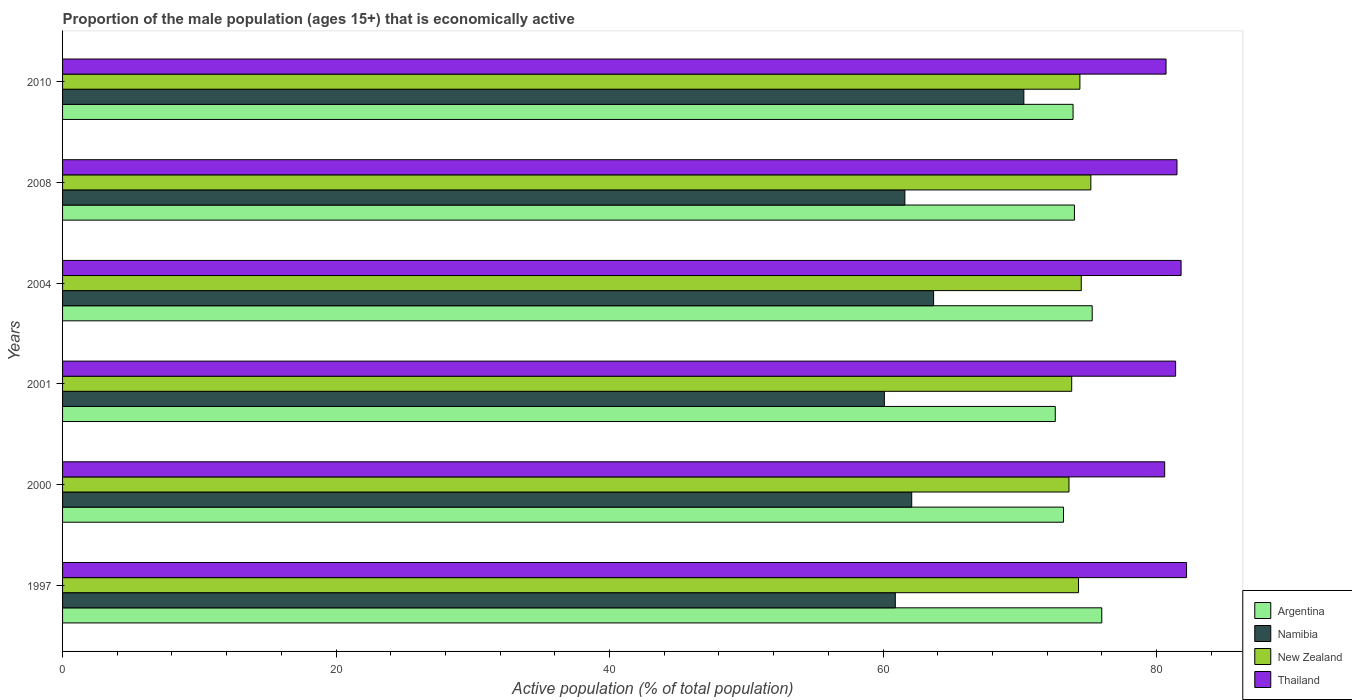How many groups of bars are there?
Ensure brevity in your answer.  6. Are the number of bars per tick equal to the number of legend labels?
Provide a succinct answer. Yes. Are the number of bars on each tick of the Y-axis equal?
Make the answer very short. Yes. How many bars are there on the 2nd tick from the top?
Provide a succinct answer. 4. What is the label of the 5th group of bars from the top?
Provide a succinct answer. 2000. What is the proportion of the male population that is economically active in Argentina in 2004?
Your answer should be compact. 75.3. Across all years, what is the maximum proportion of the male population that is economically active in Argentina?
Give a very brief answer. 76. Across all years, what is the minimum proportion of the male population that is economically active in Namibia?
Provide a short and direct response. 60.1. In which year was the proportion of the male population that is economically active in Namibia maximum?
Keep it short and to the point. 2010. What is the total proportion of the male population that is economically active in Argentina in the graph?
Make the answer very short. 445. What is the difference between the proportion of the male population that is economically active in Thailand in 2000 and that in 2008?
Make the answer very short. -0.9. What is the difference between the proportion of the male population that is economically active in New Zealand in 2010 and the proportion of the male population that is economically active in Namibia in 2000?
Make the answer very short. 12.3. What is the average proportion of the male population that is economically active in Namibia per year?
Keep it short and to the point. 63.12. In the year 2008, what is the difference between the proportion of the male population that is economically active in Namibia and proportion of the male population that is economically active in Thailand?
Your answer should be compact. -19.9. What is the ratio of the proportion of the male population that is economically active in Namibia in 2000 to that in 2008?
Give a very brief answer. 1.01. Is the proportion of the male population that is economically active in Namibia in 2000 less than that in 2001?
Your answer should be compact. No. Is the difference between the proportion of the male population that is economically active in Namibia in 2008 and 2010 greater than the difference between the proportion of the male population that is economically active in Thailand in 2008 and 2010?
Make the answer very short. No. What is the difference between the highest and the second highest proportion of the male population that is economically active in Argentina?
Your answer should be very brief. 0.7. What is the difference between the highest and the lowest proportion of the male population that is economically active in Thailand?
Offer a very short reply. 1.6. In how many years, is the proportion of the male population that is economically active in Thailand greater than the average proportion of the male population that is economically active in Thailand taken over all years?
Offer a terse response. 4. Is it the case that in every year, the sum of the proportion of the male population that is economically active in Argentina and proportion of the male population that is economically active in Namibia is greater than the sum of proportion of the male population that is economically active in Thailand and proportion of the male population that is economically active in New Zealand?
Your response must be concise. No. What does the 4th bar from the bottom in 2000 represents?
Keep it short and to the point. Thailand. Is it the case that in every year, the sum of the proportion of the male population that is economically active in New Zealand and proportion of the male population that is economically active in Thailand is greater than the proportion of the male population that is economically active in Namibia?
Keep it short and to the point. Yes. How many bars are there?
Make the answer very short. 24. What is the difference between two consecutive major ticks on the X-axis?
Your response must be concise. 20. Are the values on the major ticks of X-axis written in scientific E-notation?
Ensure brevity in your answer.  No. Does the graph contain any zero values?
Make the answer very short. No. Where does the legend appear in the graph?
Provide a succinct answer. Bottom right. How are the legend labels stacked?
Your response must be concise. Vertical. What is the title of the graph?
Your answer should be compact. Proportion of the male population (ages 15+) that is economically active. Does "Malaysia" appear as one of the legend labels in the graph?
Your response must be concise. No. What is the label or title of the X-axis?
Offer a terse response. Active population (% of total population). What is the Active population (% of total population) of Argentina in 1997?
Offer a terse response. 76. What is the Active population (% of total population) in Namibia in 1997?
Ensure brevity in your answer.  60.9. What is the Active population (% of total population) in New Zealand in 1997?
Offer a very short reply. 74.3. What is the Active population (% of total population) of Thailand in 1997?
Your answer should be very brief. 82.2. What is the Active population (% of total population) in Argentina in 2000?
Your answer should be compact. 73.2. What is the Active population (% of total population) in Namibia in 2000?
Offer a terse response. 62.1. What is the Active population (% of total population) in New Zealand in 2000?
Offer a terse response. 73.6. What is the Active population (% of total population) of Thailand in 2000?
Provide a short and direct response. 80.6. What is the Active population (% of total population) in Argentina in 2001?
Give a very brief answer. 72.6. What is the Active population (% of total population) of Namibia in 2001?
Offer a very short reply. 60.1. What is the Active population (% of total population) in New Zealand in 2001?
Your answer should be very brief. 73.8. What is the Active population (% of total population) in Thailand in 2001?
Your answer should be very brief. 81.4. What is the Active population (% of total population) in Argentina in 2004?
Give a very brief answer. 75.3. What is the Active population (% of total population) in Namibia in 2004?
Ensure brevity in your answer.  63.7. What is the Active population (% of total population) in New Zealand in 2004?
Give a very brief answer. 74.5. What is the Active population (% of total population) in Thailand in 2004?
Ensure brevity in your answer.  81.8. What is the Active population (% of total population) in Argentina in 2008?
Ensure brevity in your answer.  74. What is the Active population (% of total population) of Namibia in 2008?
Offer a terse response. 61.6. What is the Active population (% of total population) of New Zealand in 2008?
Ensure brevity in your answer.  75.2. What is the Active population (% of total population) of Thailand in 2008?
Ensure brevity in your answer.  81.5. What is the Active population (% of total population) in Argentina in 2010?
Your answer should be very brief. 73.9. What is the Active population (% of total population) in Namibia in 2010?
Give a very brief answer. 70.3. What is the Active population (% of total population) of New Zealand in 2010?
Give a very brief answer. 74.4. What is the Active population (% of total population) of Thailand in 2010?
Your response must be concise. 80.7. Across all years, what is the maximum Active population (% of total population) of Argentina?
Provide a succinct answer. 76. Across all years, what is the maximum Active population (% of total population) of Namibia?
Keep it short and to the point. 70.3. Across all years, what is the maximum Active population (% of total population) in New Zealand?
Give a very brief answer. 75.2. Across all years, what is the maximum Active population (% of total population) in Thailand?
Provide a short and direct response. 82.2. Across all years, what is the minimum Active population (% of total population) in Argentina?
Make the answer very short. 72.6. Across all years, what is the minimum Active population (% of total population) in Namibia?
Offer a terse response. 60.1. Across all years, what is the minimum Active population (% of total population) of New Zealand?
Offer a very short reply. 73.6. Across all years, what is the minimum Active population (% of total population) of Thailand?
Give a very brief answer. 80.6. What is the total Active population (% of total population) of Argentina in the graph?
Give a very brief answer. 445. What is the total Active population (% of total population) in Namibia in the graph?
Your answer should be compact. 378.7. What is the total Active population (% of total population) of New Zealand in the graph?
Ensure brevity in your answer.  445.8. What is the total Active population (% of total population) of Thailand in the graph?
Offer a very short reply. 488.2. What is the difference between the Active population (% of total population) of Argentina in 1997 and that in 2001?
Offer a very short reply. 3.4. What is the difference between the Active population (% of total population) in Thailand in 1997 and that in 2001?
Provide a short and direct response. 0.8. What is the difference between the Active population (% of total population) of Thailand in 1997 and that in 2004?
Your answer should be compact. 0.4. What is the difference between the Active population (% of total population) in Argentina in 1997 and that in 2008?
Keep it short and to the point. 2. What is the difference between the Active population (% of total population) in New Zealand in 1997 and that in 2008?
Offer a very short reply. -0.9. What is the difference between the Active population (% of total population) in Argentina in 1997 and that in 2010?
Offer a very short reply. 2.1. What is the difference between the Active population (% of total population) of Namibia in 1997 and that in 2010?
Your answer should be very brief. -9.4. What is the difference between the Active population (% of total population) of New Zealand in 1997 and that in 2010?
Give a very brief answer. -0.1. What is the difference between the Active population (% of total population) of Argentina in 2000 and that in 2001?
Make the answer very short. 0.6. What is the difference between the Active population (% of total population) in Namibia in 2000 and that in 2001?
Provide a succinct answer. 2. What is the difference between the Active population (% of total population) in New Zealand in 2000 and that in 2001?
Provide a succinct answer. -0.2. What is the difference between the Active population (% of total population) in Thailand in 2000 and that in 2001?
Your response must be concise. -0.8. What is the difference between the Active population (% of total population) of Namibia in 2000 and that in 2004?
Offer a terse response. -1.6. What is the difference between the Active population (% of total population) in Thailand in 2000 and that in 2004?
Keep it short and to the point. -1.2. What is the difference between the Active population (% of total population) in Argentina in 2000 and that in 2008?
Offer a very short reply. -0.8. What is the difference between the Active population (% of total population) in Argentina in 2000 and that in 2010?
Make the answer very short. -0.7. What is the difference between the Active population (% of total population) in Thailand in 2000 and that in 2010?
Give a very brief answer. -0.1. What is the difference between the Active population (% of total population) of Argentina in 2001 and that in 2004?
Your answer should be very brief. -2.7. What is the difference between the Active population (% of total population) of Namibia in 2001 and that in 2004?
Keep it short and to the point. -3.6. What is the difference between the Active population (% of total population) in New Zealand in 2001 and that in 2004?
Offer a terse response. -0.7. What is the difference between the Active population (% of total population) in Thailand in 2001 and that in 2004?
Provide a short and direct response. -0.4. What is the difference between the Active population (% of total population) of New Zealand in 2001 and that in 2008?
Provide a short and direct response. -1.4. What is the difference between the Active population (% of total population) of Thailand in 2001 and that in 2008?
Your answer should be very brief. -0.1. What is the difference between the Active population (% of total population) of Argentina in 2001 and that in 2010?
Give a very brief answer. -1.3. What is the difference between the Active population (% of total population) in New Zealand in 2001 and that in 2010?
Keep it short and to the point. -0.6. What is the difference between the Active population (% of total population) in Thailand in 2001 and that in 2010?
Make the answer very short. 0.7. What is the difference between the Active population (% of total population) of Argentina in 2004 and that in 2010?
Your answer should be very brief. 1.4. What is the difference between the Active population (% of total population) of Namibia in 2004 and that in 2010?
Provide a short and direct response. -6.6. What is the difference between the Active population (% of total population) of Thailand in 2004 and that in 2010?
Offer a terse response. 1.1. What is the difference between the Active population (% of total population) of New Zealand in 2008 and that in 2010?
Your answer should be very brief. 0.8. What is the difference between the Active population (% of total population) in Argentina in 1997 and the Active population (% of total population) in New Zealand in 2000?
Offer a terse response. 2.4. What is the difference between the Active population (% of total population) in Argentina in 1997 and the Active population (% of total population) in Thailand in 2000?
Your response must be concise. -4.6. What is the difference between the Active population (% of total population) in Namibia in 1997 and the Active population (% of total population) in New Zealand in 2000?
Keep it short and to the point. -12.7. What is the difference between the Active population (% of total population) in Namibia in 1997 and the Active population (% of total population) in Thailand in 2000?
Offer a terse response. -19.7. What is the difference between the Active population (% of total population) of New Zealand in 1997 and the Active population (% of total population) of Thailand in 2000?
Ensure brevity in your answer.  -6.3. What is the difference between the Active population (% of total population) of Argentina in 1997 and the Active population (% of total population) of Thailand in 2001?
Offer a terse response. -5.4. What is the difference between the Active population (% of total population) of Namibia in 1997 and the Active population (% of total population) of Thailand in 2001?
Offer a terse response. -20.5. What is the difference between the Active population (% of total population) in Namibia in 1997 and the Active population (% of total population) in Thailand in 2004?
Your answer should be very brief. -20.9. What is the difference between the Active population (% of total population) of Argentina in 1997 and the Active population (% of total population) of New Zealand in 2008?
Make the answer very short. 0.8. What is the difference between the Active population (% of total population) of Namibia in 1997 and the Active population (% of total population) of New Zealand in 2008?
Your answer should be very brief. -14.3. What is the difference between the Active population (% of total population) of Namibia in 1997 and the Active population (% of total population) of Thailand in 2008?
Provide a short and direct response. -20.6. What is the difference between the Active population (% of total population) of Argentina in 1997 and the Active population (% of total population) of Namibia in 2010?
Your response must be concise. 5.7. What is the difference between the Active population (% of total population) in Argentina in 1997 and the Active population (% of total population) in Thailand in 2010?
Provide a short and direct response. -4.7. What is the difference between the Active population (% of total population) in Namibia in 1997 and the Active population (% of total population) in New Zealand in 2010?
Ensure brevity in your answer.  -13.5. What is the difference between the Active population (% of total population) in Namibia in 1997 and the Active population (% of total population) in Thailand in 2010?
Your response must be concise. -19.8. What is the difference between the Active population (% of total population) in New Zealand in 1997 and the Active population (% of total population) in Thailand in 2010?
Your answer should be compact. -6.4. What is the difference between the Active population (% of total population) in Argentina in 2000 and the Active population (% of total population) in New Zealand in 2001?
Your answer should be compact. -0.6. What is the difference between the Active population (% of total population) in Argentina in 2000 and the Active population (% of total population) in Thailand in 2001?
Your answer should be very brief. -8.2. What is the difference between the Active population (% of total population) in Namibia in 2000 and the Active population (% of total population) in New Zealand in 2001?
Offer a very short reply. -11.7. What is the difference between the Active population (% of total population) in Namibia in 2000 and the Active population (% of total population) in Thailand in 2001?
Make the answer very short. -19.3. What is the difference between the Active population (% of total population) in New Zealand in 2000 and the Active population (% of total population) in Thailand in 2001?
Give a very brief answer. -7.8. What is the difference between the Active population (% of total population) of Argentina in 2000 and the Active population (% of total population) of New Zealand in 2004?
Provide a succinct answer. -1.3. What is the difference between the Active population (% of total population) in Argentina in 2000 and the Active population (% of total population) in Thailand in 2004?
Offer a very short reply. -8.6. What is the difference between the Active population (% of total population) of Namibia in 2000 and the Active population (% of total population) of Thailand in 2004?
Your answer should be compact. -19.7. What is the difference between the Active population (% of total population) in Argentina in 2000 and the Active population (% of total population) in New Zealand in 2008?
Your answer should be very brief. -2. What is the difference between the Active population (% of total population) in Namibia in 2000 and the Active population (% of total population) in New Zealand in 2008?
Your response must be concise. -13.1. What is the difference between the Active population (% of total population) of Namibia in 2000 and the Active population (% of total population) of Thailand in 2008?
Keep it short and to the point. -19.4. What is the difference between the Active population (% of total population) in New Zealand in 2000 and the Active population (% of total population) in Thailand in 2008?
Ensure brevity in your answer.  -7.9. What is the difference between the Active population (% of total population) of Argentina in 2000 and the Active population (% of total population) of Namibia in 2010?
Make the answer very short. 2.9. What is the difference between the Active population (% of total population) in Argentina in 2000 and the Active population (% of total population) in New Zealand in 2010?
Your response must be concise. -1.2. What is the difference between the Active population (% of total population) of Argentina in 2000 and the Active population (% of total population) of Thailand in 2010?
Your answer should be compact. -7.5. What is the difference between the Active population (% of total population) in Namibia in 2000 and the Active population (% of total population) in New Zealand in 2010?
Provide a succinct answer. -12.3. What is the difference between the Active population (% of total population) in Namibia in 2000 and the Active population (% of total population) in Thailand in 2010?
Your answer should be very brief. -18.6. What is the difference between the Active population (% of total population) in New Zealand in 2000 and the Active population (% of total population) in Thailand in 2010?
Provide a short and direct response. -7.1. What is the difference between the Active population (% of total population) in Argentina in 2001 and the Active population (% of total population) in New Zealand in 2004?
Make the answer very short. -1.9. What is the difference between the Active population (% of total population) in Argentina in 2001 and the Active population (% of total population) in Thailand in 2004?
Make the answer very short. -9.2. What is the difference between the Active population (% of total population) in Namibia in 2001 and the Active population (% of total population) in New Zealand in 2004?
Offer a very short reply. -14.4. What is the difference between the Active population (% of total population) of Namibia in 2001 and the Active population (% of total population) of Thailand in 2004?
Your response must be concise. -21.7. What is the difference between the Active population (% of total population) in Argentina in 2001 and the Active population (% of total population) in Thailand in 2008?
Provide a succinct answer. -8.9. What is the difference between the Active population (% of total population) in Namibia in 2001 and the Active population (% of total population) in New Zealand in 2008?
Give a very brief answer. -15.1. What is the difference between the Active population (% of total population) in Namibia in 2001 and the Active population (% of total population) in Thailand in 2008?
Your response must be concise. -21.4. What is the difference between the Active population (% of total population) in New Zealand in 2001 and the Active population (% of total population) in Thailand in 2008?
Your response must be concise. -7.7. What is the difference between the Active population (% of total population) of Argentina in 2001 and the Active population (% of total population) of Namibia in 2010?
Your answer should be very brief. 2.3. What is the difference between the Active population (% of total population) of Argentina in 2001 and the Active population (% of total population) of Thailand in 2010?
Provide a short and direct response. -8.1. What is the difference between the Active population (% of total population) of Namibia in 2001 and the Active population (% of total population) of New Zealand in 2010?
Make the answer very short. -14.3. What is the difference between the Active population (% of total population) in Namibia in 2001 and the Active population (% of total population) in Thailand in 2010?
Ensure brevity in your answer.  -20.6. What is the difference between the Active population (% of total population) in Argentina in 2004 and the Active population (% of total population) in Namibia in 2008?
Ensure brevity in your answer.  13.7. What is the difference between the Active population (% of total population) in Namibia in 2004 and the Active population (% of total population) in Thailand in 2008?
Ensure brevity in your answer.  -17.8. What is the difference between the Active population (% of total population) of New Zealand in 2004 and the Active population (% of total population) of Thailand in 2008?
Offer a terse response. -7. What is the difference between the Active population (% of total population) of Namibia in 2004 and the Active population (% of total population) of New Zealand in 2010?
Ensure brevity in your answer.  -10.7. What is the difference between the Active population (% of total population) of Namibia in 2004 and the Active population (% of total population) of Thailand in 2010?
Your answer should be compact. -17. What is the difference between the Active population (% of total population) in Argentina in 2008 and the Active population (% of total population) in Namibia in 2010?
Ensure brevity in your answer.  3.7. What is the difference between the Active population (% of total population) of Argentina in 2008 and the Active population (% of total population) of Thailand in 2010?
Your answer should be very brief. -6.7. What is the difference between the Active population (% of total population) of Namibia in 2008 and the Active population (% of total population) of New Zealand in 2010?
Keep it short and to the point. -12.8. What is the difference between the Active population (% of total population) of Namibia in 2008 and the Active population (% of total population) of Thailand in 2010?
Give a very brief answer. -19.1. What is the average Active population (% of total population) in Argentina per year?
Give a very brief answer. 74.17. What is the average Active population (% of total population) in Namibia per year?
Ensure brevity in your answer.  63.12. What is the average Active population (% of total population) of New Zealand per year?
Keep it short and to the point. 74.3. What is the average Active population (% of total population) of Thailand per year?
Ensure brevity in your answer.  81.37. In the year 1997, what is the difference between the Active population (% of total population) of Argentina and Active population (% of total population) of New Zealand?
Make the answer very short. 1.7. In the year 1997, what is the difference between the Active population (% of total population) in Namibia and Active population (% of total population) in Thailand?
Give a very brief answer. -21.3. In the year 2000, what is the difference between the Active population (% of total population) in Argentina and Active population (% of total population) in Namibia?
Your answer should be compact. 11.1. In the year 2000, what is the difference between the Active population (% of total population) in Argentina and Active population (% of total population) in Thailand?
Provide a short and direct response. -7.4. In the year 2000, what is the difference between the Active population (% of total population) in Namibia and Active population (% of total population) in New Zealand?
Make the answer very short. -11.5. In the year 2000, what is the difference between the Active population (% of total population) in Namibia and Active population (% of total population) in Thailand?
Ensure brevity in your answer.  -18.5. In the year 2000, what is the difference between the Active population (% of total population) in New Zealand and Active population (% of total population) in Thailand?
Provide a succinct answer. -7. In the year 2001, what is the difference between the Active population (% of total population) of Argentina and Active population (% of total population) of New Zealand?
Provide a succinct answer. -1.2. In the year 2001, what is the difference between the Active population (% of total population) of Namibia and Active population (% of total population) of New Zealand?
Give a very brief answer. -13.7. In the year 2001, what is the difference between the Active population (% of total population) in Namibia and Active population (% of total population) in Thailand?
Keep it short and to the point. -21.3. In the year 2001, what is the difference between the Active population (% of total population) of New Zealand and Active population (% of total population) of Thailand?
Offer a very short reply. -7.6. In the year 2004, what is the difference between the Active population (% of total population) in Argentina and Active population (% of total population) in Namibia?
Provide a succinct answer. 11.6. In the year 2004, what is the difference between the Active population (% of total population) of Argentina and Active population (% of total population) of Thailand?
Offer a terse response. -6.5. In the year 2004, what is the difference between the Active population (% of total population) of Namibia and Active population (% of total population) of New Zealand?
Give a very brief answer. -10.8. In the year 2004, what is the difference between the Active population (% of total population) of Namibia and Active population (% of total population) of Thailand?
Give a very brief answer. -18.1. In the year 2004, what is the difference between the Active population (% of total population) in New Zealand and Active population (% of total population) in Thailand?
Your response must be concise. -7.3. In the year 2008, what is the difference between the Active population (% of total population) in Argentina and Active population (% of total population) in Thailand?
Your response must be concise. -7.5. In the year 2008, what is the difference between the Active population (% of total population) of Namibia and Active population (% of total population) of Thailand?
Your answer should be very brief. -19.9. In the year 2008, what is the difference between the Active population (% of total population) of New Zealand and Active population (% of total population) of Thailand?
Your answer should be very brief. -6.3. In the year 2010, what is the difference between the Active population (% of total population) of Argentina and Active population (% of total population) of Namibia?
Your answer should be very brief. 3.6. In the year 2010, what is the difference between the Active population (% of total population) of New Zealand and Active population (% of total population) of Thailand?
Offer a very short reply. -6.3. What is the ratio of the Active population (% of total population) in Argentina in 1997 to that in 2000?
Your response must be concise. 1.04. What is the ratio of the Active population (% of total population) of Namibia in 1997 to that in 2000?
Offer a terse response. 0.98. What is the ratio of the Active population (% of total population) in New Zealand in 1997 to that in 2000?
Your response must be concise. 1.01. What is the ratio of the Active population (% of total population) of Thailand in 1997 to that in 2000?
Provide a succinct answer. 1.02. What is the ratio of the Active population (% of total population) of Argentina in 1997 to that in 2001?
Offer a terse response. 1.05. What is the ratio of the Active population (% of total population) in Namibia in 1997 to that in 2001?
Your answer should be very brief. 1.01. What is the ratio of the Active population (% of total population) in New Zealand in 1997 to that in 2001?
Make the answer very short. 1.01. What is the ratio of the Active population (% of total population) in Thailand in 1997 to that in 2001?
Provide a succinct answer. 1.01. What is the ratio of the Active population (% of total population) of Argentina in 1997 to that in 2004?
Your answer should be very brief. 1.01. What is the ratio of the Active population (% of total population) in Namibia in 1997 to that in 2004?
Your answer should be compact. 0.96. What is the ratio of the Active population (% of total population) in New Zealand in 1997 to that in 2004?
Your answer should be compact. 1. What is the ratio of the Active population (% of total population) in Thailand in 1997 to that in 2004?
Keep it short and to the point. 1. What is the ratio of the Active population (% of total population) in Argentina in 1997 to that in 2008?
Provide a succinct answer. 1.03. What is the ratio of the Active population (% of total population) of Namibia in 1997 to that in 2008?
Keep it short and to the point. 0.99. What is the ratio of the Active population (% of total population) of New Zealand in 1997 to that in 2008?
Provide a succinct answer. 0.99. What is the ratio of the Active population (% of total population) in Thailand in 1997 to that in 2008?
Your answer should be compact. 1.01. What is the ratio of the Active population (% of total population) of Argentina in 1997 to that in 2010?
Your answer should be very brief. 1.03. What is the ratio of the Active population (% of total population) in Namibia in 1997 to that in 2010?
Provide a short and direct response. 0.87. What is the ratio of the Active population (% of total population) in New Zealand in 1997 to that in 2010?
Offer a very short reply. 1. What is the ratio of the Active population (% of total population) in Thailand in 1997 to that in 2010?
Provide a succinct answer. 1.02. What is the ratio of the Active population (% of total population) in Argentina in 2000 to that in 2001?
Ensure brevity in your answer.  1.01. What is the ratio of the Active population (% of total population) in Thailand in 2000 to that in 2001?
Your answer should be compact. 0.99. What is the ratio of the Active population (% of total population) in Argentina in 2000 to that in 2004?
Provide a short and direct response. 0.97. What is the ratio of the Active population (% of total population) of Namibia in 2000 to that in 2004?
Provide a short and direct response. 0.97. What is the ratio of the Active population (% of total population) in New Zealand in 2000 to that in 2004?
Provide a succinct answer. 0.99. What is the ratio of the Active population (% of total population) in Thailand in 2000 to that in 2004?
Offer a very short reply. 0.99. What is the ratio of the Active population (% of total population) of Argentina in 2000 to that in 2008?
Ensure brevity in your answer.  0.99. What is the ratio of the Active population (% of total population) in Namibia in 2000 to that in 2008?
Give a very brief answer. 1.01. What is the ratio of the Active population (% of total population) in New Zealand in 2000 to that in 2008?
Your response must be concise. 0.98. What is the ratio of the Active population (% of total population) in Thailand in 2000 to that in 2008?
Make the answer very short. 0.99. What is the ratio of the Active population (% of total population) in Argentina in 2000 to that in 2010?
Ensure brevity in your answer.  0.99. What is the ratio of the Active population (% of total population) of Namibia in 2000 to that in 2010?
Ensure brevity in your answer.  0.88. What is the ratio of the Active population (% of total population) of Thailand in 2000 to that in 2010?
Your answer should be very brief. 1. What is the ratio of the Active population (% of total population) of Argentina in 2001 to that in 2004?
Your response must be concise. 0.96. What is the ratio of the Active population (% of total population) in Namibia in 2001 to that in 2004?
Your answer should be very brief. 0.94. What is the ratio of the Active population (% of total population) of New Zealand in 2001 to that in 2004?
Give a very brief answer. 0.99. What is the ratio of the Active population (% of total population) of Argentina in 2001 to that in 2008?
Your response must be concise. 0.98. What is the ratio of the Active population (% of total population) in Namibia in 2001 to that in 2008?
Your answer should be very brief. 0.98. What is the ratio of the Active population (% of total population) in New Zealand in 2001 to that in 2008?
Your answer should be compact. 0.98. What is the ratio of the Active population (% of total population) of Argentina in 2001 to that in 2010?
Give a very brief answer. 0.98. What is the ratio of the Active population (% of total population) in Namibia in 2001 to that in 2010?
Make the answer very short. 0.85. What is the ratio of the Active population (% of total population) of New Zealand in 2001 to that in 2010?
Provide a succinct answer. 0.99. What is the ratio of the Active population (% of total population) of Thailand in 2001 to that in 2010?
Provide a short and direct response. 1.01. What is the ratio of the Active population (% of total population) in Argentina in 2004 to that in 2008?
Make the answer very short. 1.02. What is the ratio of the Active population (% of total population) of Namibia in 2004 to that in 2008?
Offer a very short reply. 1.03. What is the ratio of the Active population (% of total population) in New Zealand in 2004 to that in 2008?
Keep it short and to the point. 0.99. What is the ratio of the Active population (% of total population) of Thailand in 2004 to that in 2008?
Provide a short and direct response. 1. What is the ratio of the Active population (% of total population) in Argentina in 2004 to that in 2010?
Provide a succinct answer. 1.02. What is the ratio of the Active population (% of total population) in Namibia in 2004 to that in 2010?
Your response must be concise. 0.91. What is the ratio of the Active population (% of total population) of Thailand in 2004 to that in 2010?
Ensure brevity in your answer.  1.01. What is the ratio of the Active population (% of total population) in Argentina in 2008 to that in 2010?
Your answer should be very brief. 1. What is the ratio of the Active population (% of total population) of Namibia in 2008 to that in 2010?
Keep it short and to the point. 0.88. What is the ratio of the Active population (% of total population) of New Zealand in 2008 to that in 2010?
Keep it short and to the point. 1.01. What is the ratio of the Active population (% of total population) of Thailand in 2008 to that in 2010?
Provide a succinct answer. 1.01. What is the difference between the highest and the second highest Active population (% of total population) of Namibia?
Your response must be concise. 6.6. What is the difference between the highest and the second highest Active population (% of total population) of Thailand?
Make the answer very short. 0.4. What is the difference between the highest and the lowest Active population (% of total population) in Namibia?
Ensure brevity in your answer.  10.2. What is the difference between the highest and the lowest Active population (% of total population) in New Zealand?
Offer a very short reply. 1.6. What is the difference between the highest and the lowest Active population (% of total population) in Thailand?
Your answer should be compact. 1.6. 